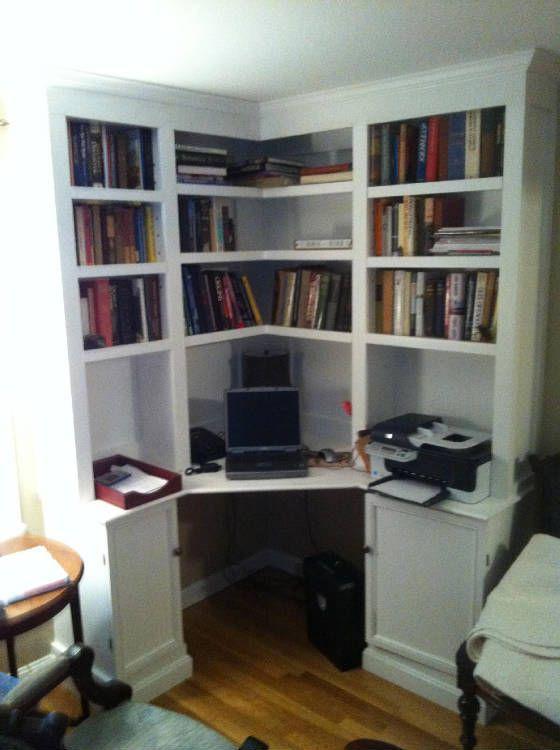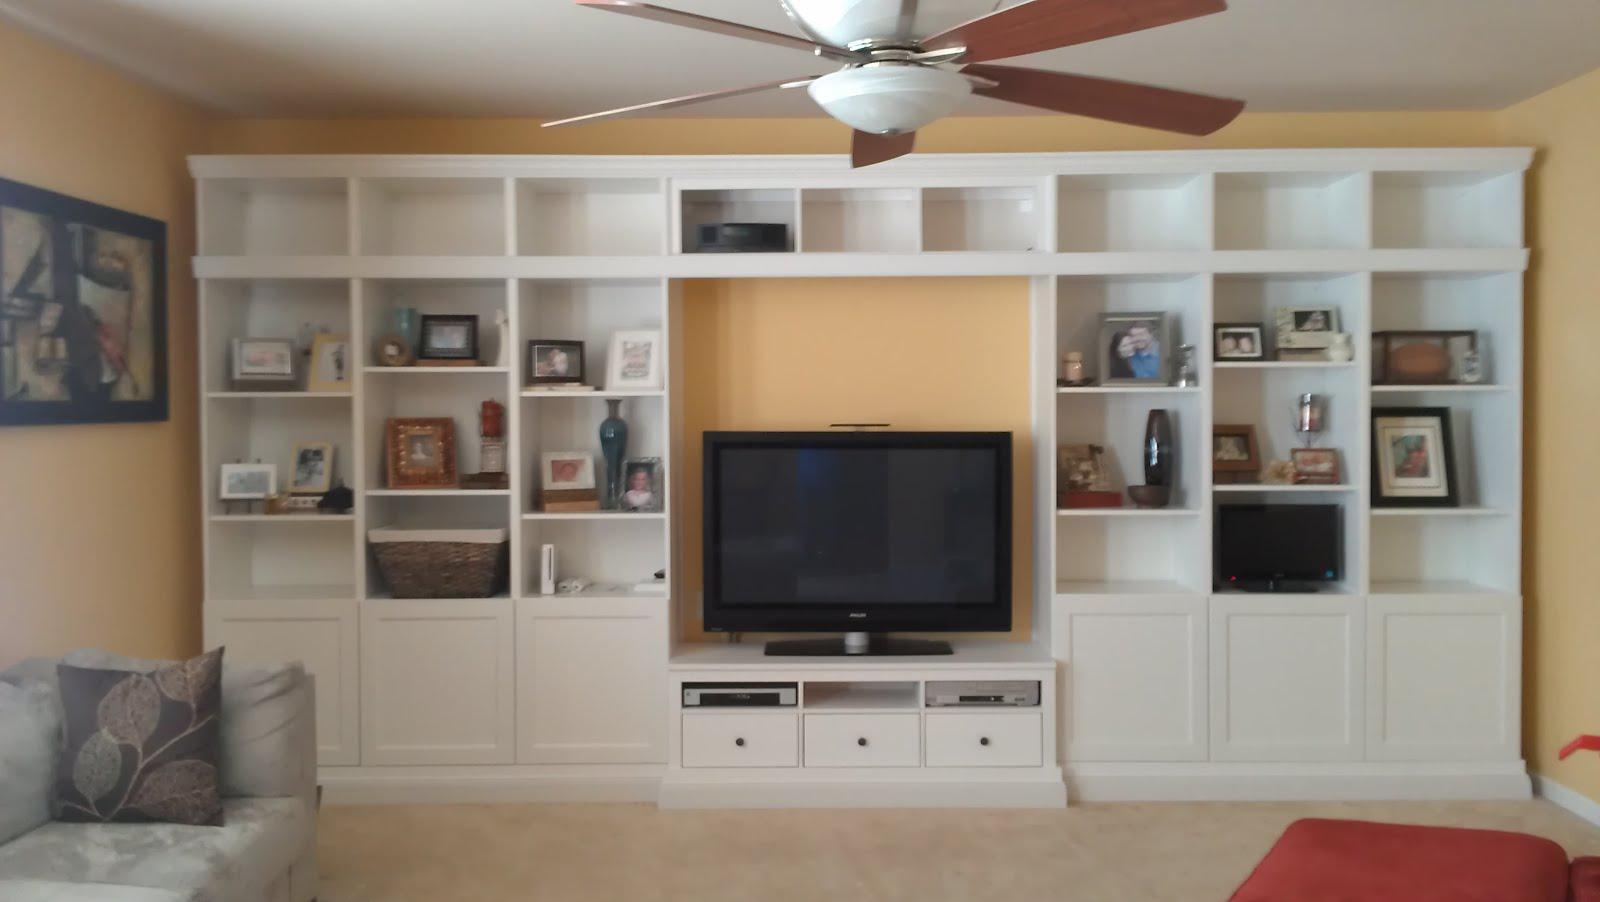The first image is the image on the left, the second image is the image on the right. For the images shown, is this caption "One bookcase nearly fills a wall and has a counter in the center flanked by at least two rows of shelves and two cabinets on either side." true? Answer yes or no. Yes. The first image is the image on the left, the second image is the image on the right. Examine the images to the left and right. Is the description "There is a four legged chair at each of the white desk areas." accurate? Answer yes or no. No. 